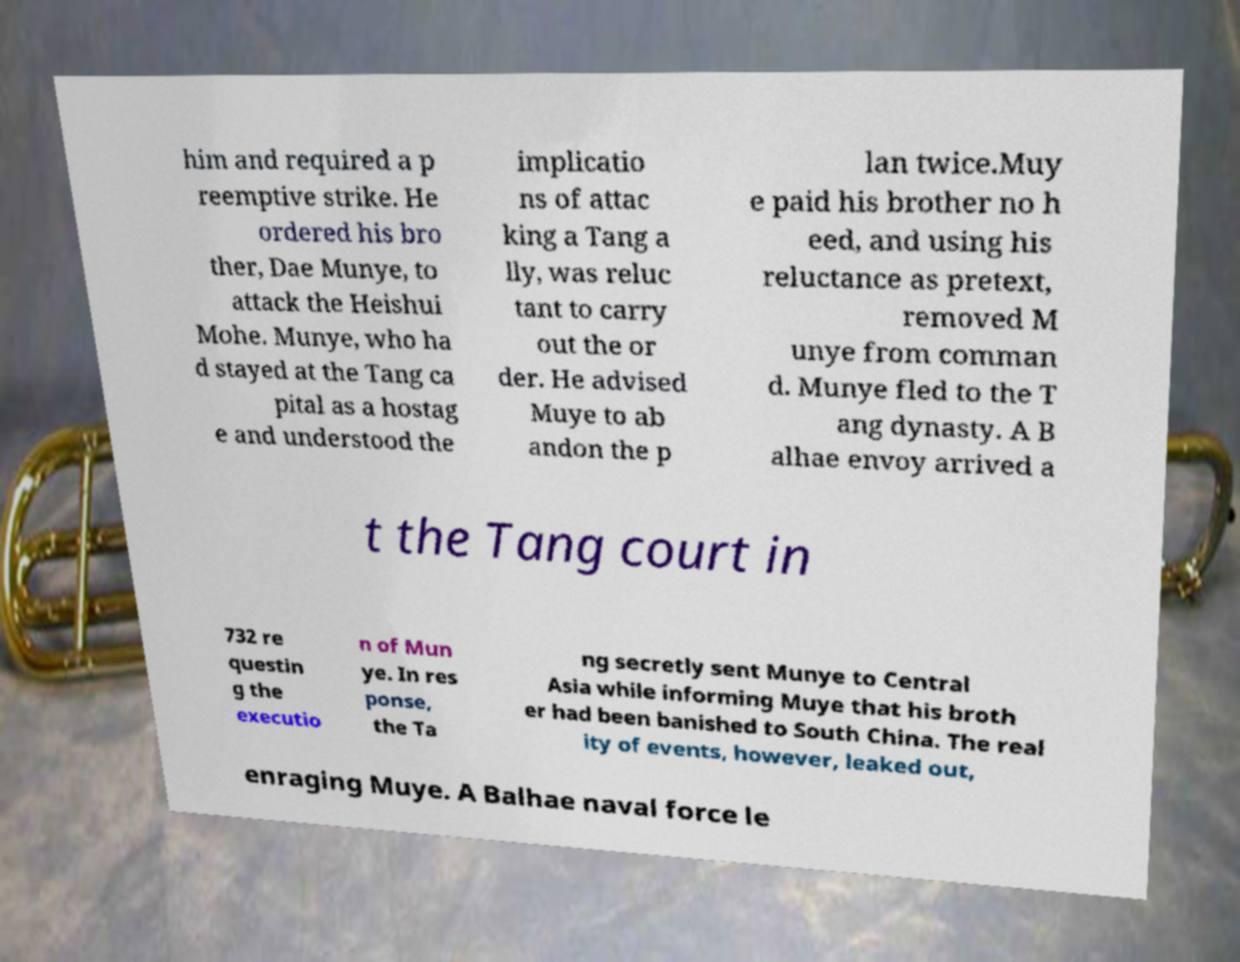What messages or text are displayed in this image? I need them in a readable, typed format. him and required a p reemptive strike. He ordered his bro ther, Dae Munye, to attack the Heishui Mohe. Munye, who ha d stayed at the Tang ca pital as a hostag e and understood the implicatio ns of attac king a Tang a lly, was reluc tant to carry out the or der. He advised Muye to ab andon the p lan twice.Muy e paid his brother no h eed, and using his reluctance as pretext, removed M unye from comman d. Munye fled to the T ang dynasty. A B alhae envoy arrived a t the Tang court in 732 re questin g the executio n of Mun ye. In res ponse, the Ta ng secretly sent Munye to Central Asia while informing Muye that his broth er had been banished to South China. The real ity of events, however, leaked out, enraging Muye. A Balhae naval force le 